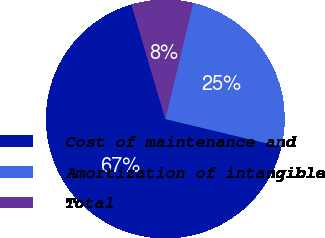<chart> <loc_0><loc_0><loc_500><loc_500><pie_chart><fcel>Cost of maintenance and<fcel>Amortization of intangible<fcel>Total<nl><fcel>66.67%<fcel>25.0%<fcel>8.33%<nl></chart> 